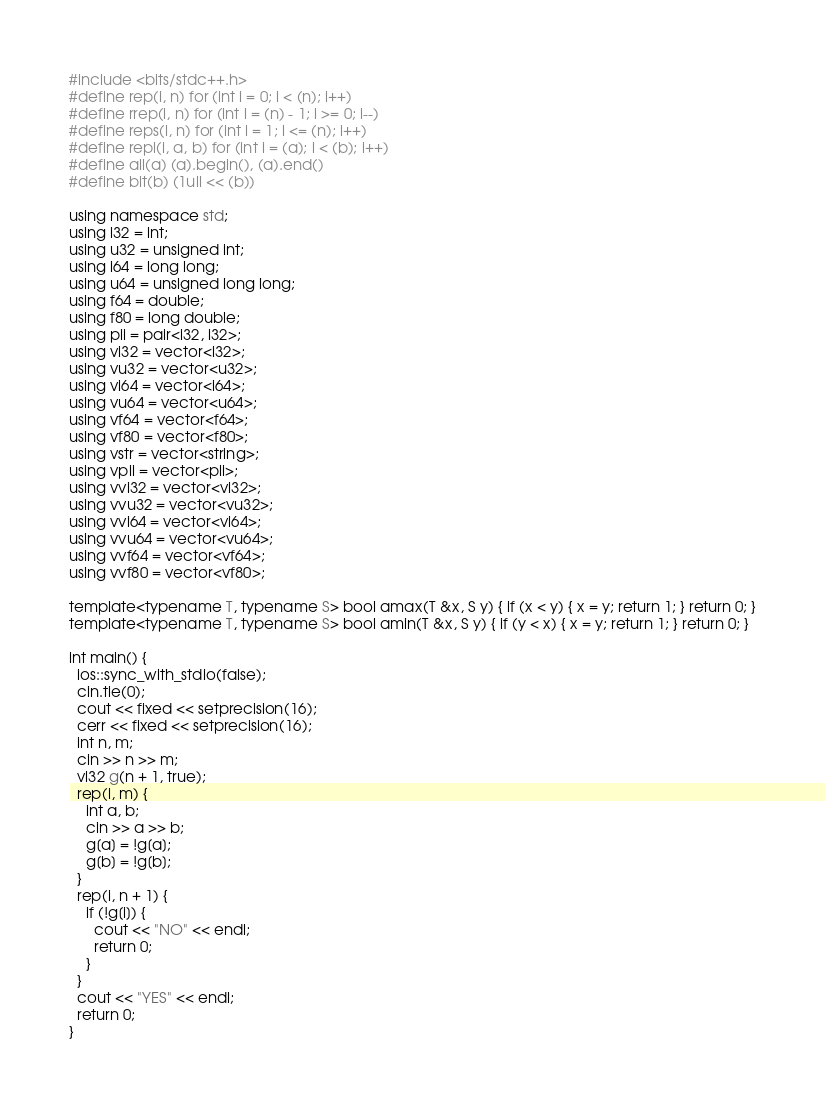Convert code to text. <code><loc_0><loc_0><loc_500><loc_500><_C++_>#include <bits/stdc++.h>
#define rep(i, n) for (int i = 0; i < (n); i++)
#define rrep(i, n) for (int i = (n) - 1; i >= 0; i--)
#define reps(i, n) for (int i = 1; i <= (n); i++)
#define repi(i, a, b) for (int i = (a); i < (b); i++)
#define all(a) (a).begin(), (a).end()
#define bit(b) (1ull << (b))

using namespace std;
using i32 = int;
using u32 = unsigned int;
using i64 = long long;
using u64 = unsigned long long;
using f64 = double;
using f80 = long double;
using pii = pair<i32, i32>;
using vi32 = vector<i32>;
using vu32 = vector<u32>;
using vi64 = vector<i64>;
using vu64 = vector<u64>;
using vf64 = vector<f64>;
using vf80 = vector<f80>;
using vstr = vector<string>;
using vpii = vector<pii>;
using vvi32 = vector<vi32>;
using vvu32 = vector<vu32>;
using vvi64 = vector<vi64>;
using vvu64 = vector<vu64>;
using vvf64 = vector<vf64>;
using vvf80 = vector<vf80>;

template<typename T, typename S> bool amax(T &x, S y) { if (x < y) { x = y; return 1; } return 0; }
template<typename T, typename S> bool amin(T &x, S y) { if (y < x) { x = y; return 1; } return 0; }

int main() {
  ios::sync_with_stdio(false);
  cin.tie(0);
  cout << fixed << setprecision(16);
  cerr << fixed << setprecision(16);
  int n, m;
  cin >> n >> m;
  vi32 g(n + 1, true);
  rep(i, m) {
    int a, b;
    cin >> a >> b;
    g[a] = !g[a];
    g[b] = !g[b];
  }
  rep(i, n + 1) {
    if (!g[i]) {
      cout << "NO" << endl;
      return 0;
    }
  }
  cout << "YES" << endl;
  return 0;
}</code> 